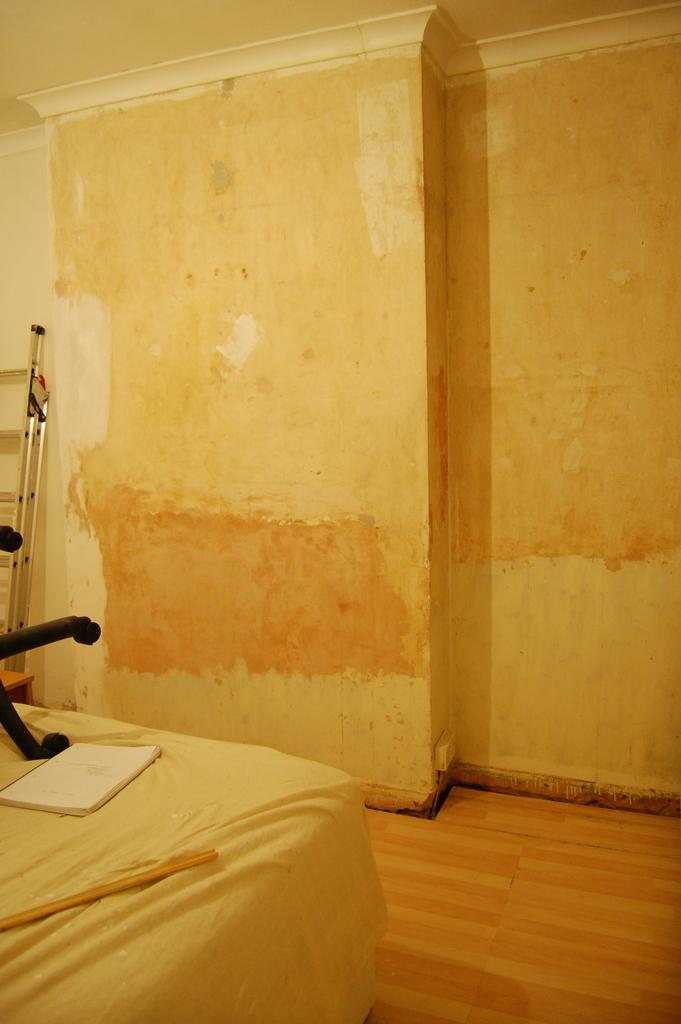What piece of furniture is located in the bottom left of the image? There is a bed in the bottom left of the image. What can be found on top of the bed? There are objects on the bed. What is the main feature at the top of the image? There is a wall at the top of the image. What type of scent can be detected from the cloth on the bed in the image? There is no cloth mentioned in the image, and therefore no scent can be detected. 